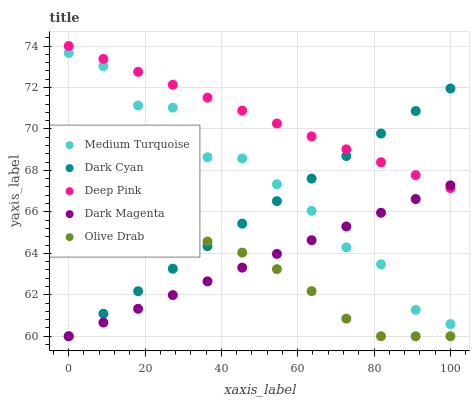Does Olive Drab have the minimum area under the curve?
Answer yes or no. Yes. Does Deep Pink have the maximum area under the curve?
Answer yes or no. Yes. Does Deep Pink have the minimum area under the curve?
Answer yes or no. No. Does Olive Drab have the maximum area under the curve?
Answer yes or no. No. Is Dark Cyan the smoothest?
Answer yes or no. Yes. Is Medium Turquoise the roughest?
Answer yes or no. Yes. Is Olive Drab the smoothest?
Answer yes or no. No. Is Olive Drab the roughest?
Answer yes or no. No. Does Dark Cyan have the lowest value?
Answer yes or no. Yes. Does Deep Pink have the lowest value?
Answer yes or no. No. Does Deep Pink have the highest value?
Answer yes or no. Yes. Does Olive Drab have the highest value?
Answer yes or no. No. Is Olive Drab less than Deep Pink?
Answer yes or no. Yes. Is Deep Pink greater than Medium Turquoise?
Answer yes or no. Yes. Does Dark Magenta intersect Olive Drab?
Answer yes or no. Yes. Is Dark Magenta less than Olive Drab?
Answer yes or no. No. Is Dark Magenta greater than Olive Drab?
Answer yes or no. No. Does Olive Drab intersect Deep Pink?
Answer yes or no. No. 